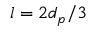Convert formula to latex. <formula><loc_0><loc_0><loc_500><loc_500>l = 2 d _ { p } / 3</formula> 